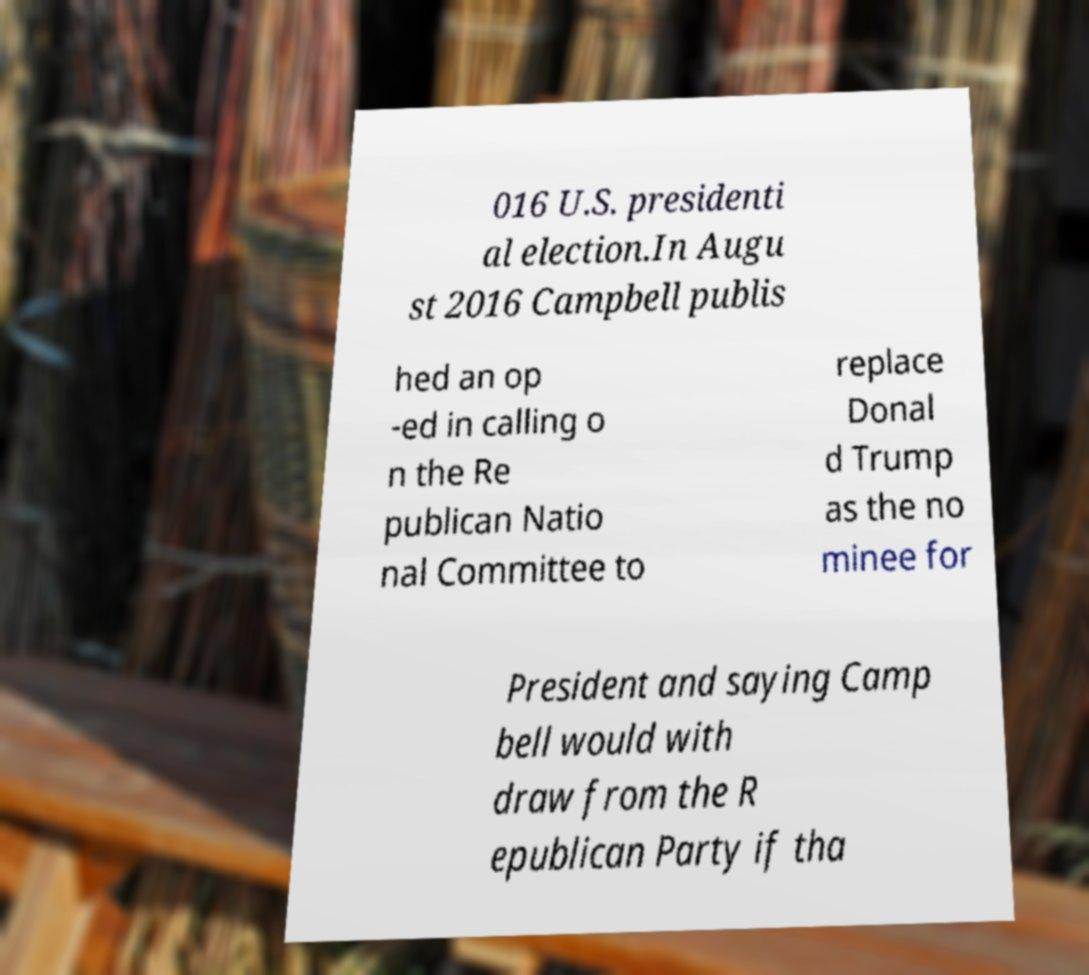Could you assist in decoding the text presented in this image and type it out clearly? 016 U.S. presidenti al election.In Augu st 2016 Campbell publis hed an op -ed in calling o n the Re publican Natio nal Committee to replace Donal d Trump as the no minee for President and saying Camp bell would with draw from the R epublican Party if tha 